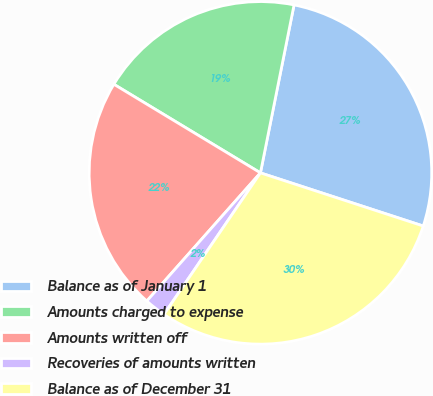Convert chart. <chart><loc_0><loc_0><loc_500><loc_500><pie_chart><fcel>Balance as of January 1<fcel>Amounts charged to expense<fcel>Amounts written off<fcel>Recoveries of amounts written<fcel>Balance as of December 31<nl><fcel>26.88%<fcel>19.49%<fcel>22.11%<fcel>2.02%<fcel>29.5%<nl></chart> 